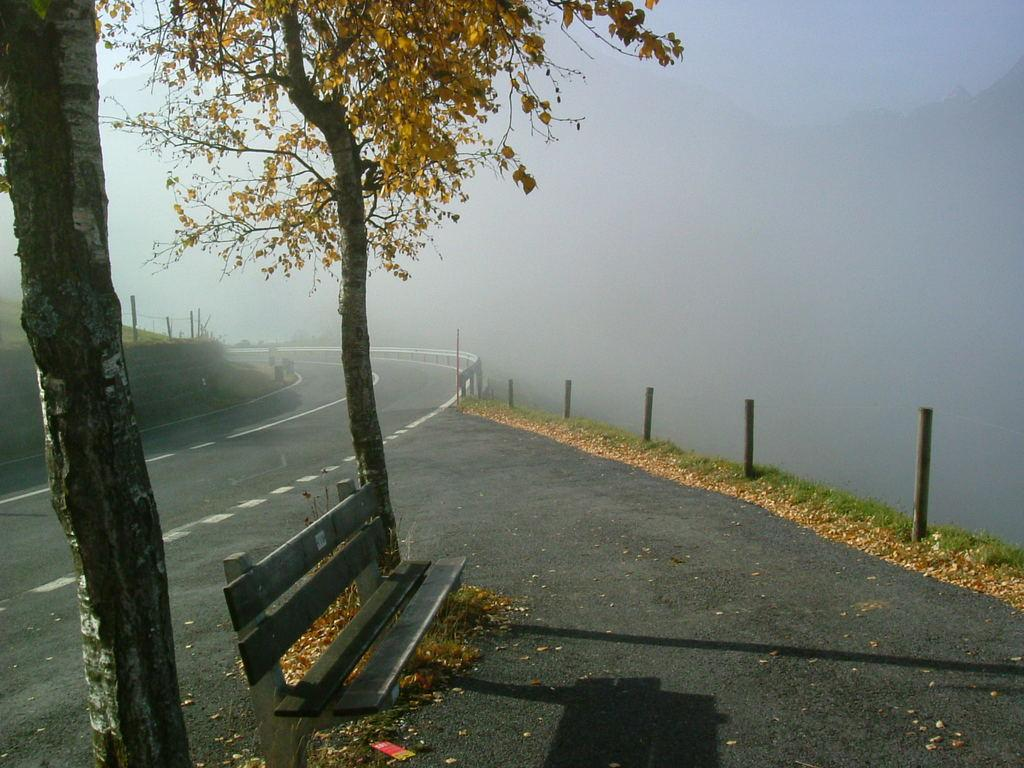What type of vegetation can be seen in the image? There are trees in the image. What type of seating is present in the image? There is a bench in the image. What type of structures can be seen in the image? There are rods and railing in the image. What type of pathway is visible in the image? There is a road in the image. What type of weather condition can be observed in the background of the image? There is fog in the background of the image. What type of berry is growing on the bench in the image? There are no berries present in the image, and the bench is not a place where berries would typically grow. 